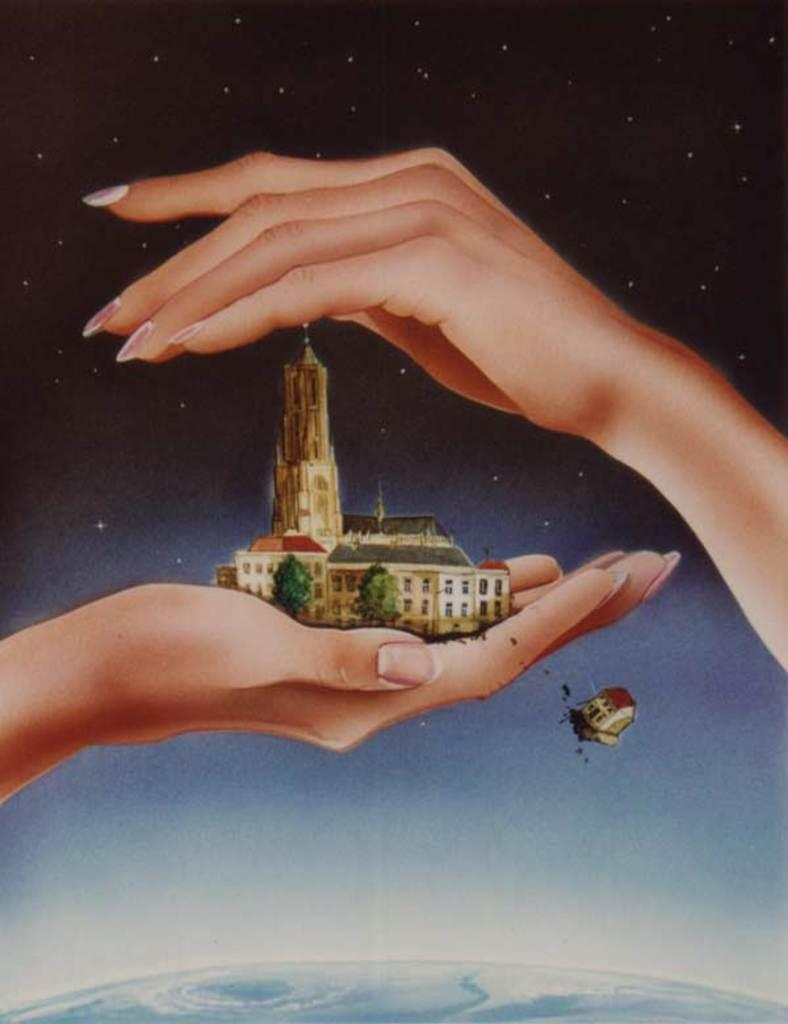What is at the bottom of the image? There is earth at the bottom of the image. What can be seen in the person's hand in the image? There are buildings and trees visible in the person's hand in the image. How many hands are present in the image? There are two hands present in the image. What can be seen in the background of the image? Stars are visible in the background of the image. Can you see the ocean in the image? There is no ocean present in the image; it features earth, buildings, trees, stars, and hands. Is there a war happening in the image? There is no indication of a war or any conflict in the image. 